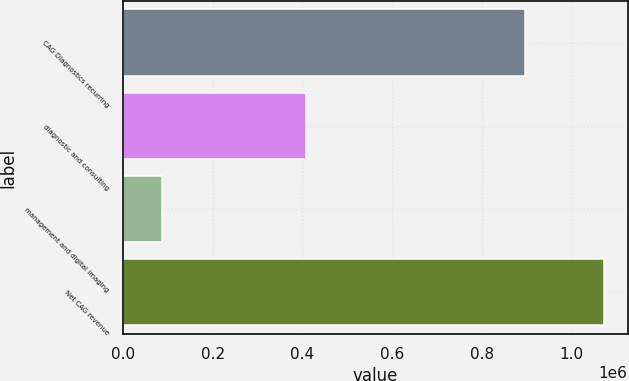<chart> <loc_0><loc_0><loc_500><loc_500><bar_chart><fcel>CAG Diagnostics recurring<fcel>diagnostic and consulting<fcel>management and digital imaging<fcel>Net CAG revenue<nl><fcel>896449<fcel>407343<fcel>85585<fcel>1.07221e+06<nl></chart> 